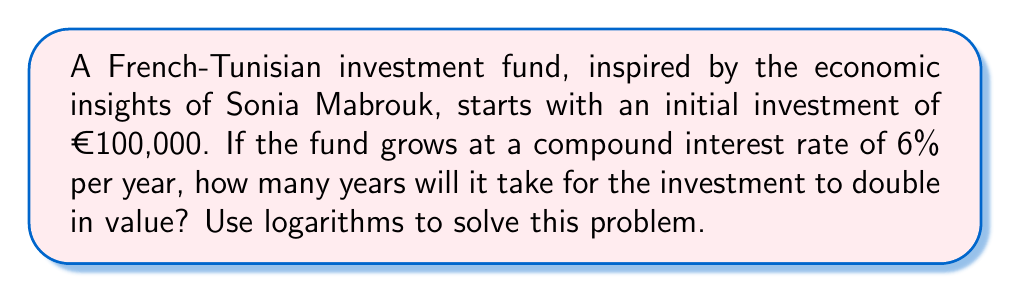Help me with this question. Let's approach this step-by-step using the compound interest formula and logarithms:

1) The compound interest formula is:
   $A = P(1 + r)^t$
   Where:
   $A$ = final amount
   $P$ = principal (initial investment)
   $r$ = annual interest rate (as a decimal)
   $t$ = time in years

2) We want to find when the investment doubles, so:
   $A = 2P$

3) Substituting into the formula:
   $2P = P(1 + 0.06)^t$

4) Simplify:
   $2 = (1.06)^t$

5) Take the natural logarithm of both sides:
   $\ln(2) = \ln((1.06)^t)$

6) Use the logarithm property $\ln(a^b) = b\ln(a)$:
   $\ln(2) = t\ln(1.06)$

7) Solve for $t$:
   $t = \frac{\ln(2)}{\ln(1.06)}$

8) Calculate:
   $t = \frac{0.6931471806}{0.0582689492} \approx 11.90$ years

Therefore, it will take approximately 11.90 years for the investment to double.
Answer: 11.90 years 